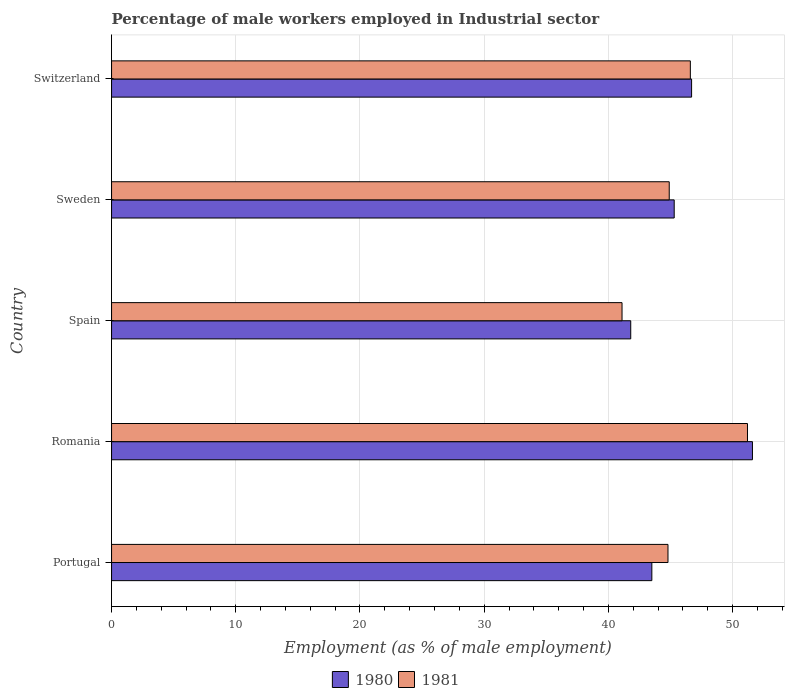How many groups of bars are there?
Offer a terse response. 5. In how many cases, is the number of bars for a given country not equal to the number of legend labels?
Provide a succinct answer. 0. What is the percentage of male workers employed in Industrial sector in 1980 in Portugal?
Your answer should be compact. 43.5. Across all countries, what is the maximum percentage of male workers employed in Industrial sector in 1981?
Offer a very short reply. 51.2. Across all countries, what is the minimum percentage of male workers employed in Industrial sector in 1981?
Offer a very short reply. 41.1. In which country was the percentage of male workers employed in Industrial sector in 1980 maximum?
Your response must be concise. Romania. In which country was the percentage of male workers employed in Industrial sector in 1981 minimum?
Keep it short and to the point. Spain. What is the total percentage of male workers employed in Industrial sector in 1981 in the graph?
Keep it short and to the point. 228.6. What is the difference between the percentage of male workers employed in Industrial sector in 1981 in Spain and that in Sweden?
Your answer should be compact. -3.8. What is the difference between the percentage of male workers employed in Industrial sector in 1981 in Romania and the percentage of male workers employed in Industrial sector in 1980 in Sweden?
Offer a terse response. 5.9. What is the average percentage of male workers employed in Industrial sector in 1981 per country?
Provide a succinct answer. 45.72. What is the difference between the percentage of male workers employed in Industrial sector in 1981 and percentage of male workers employed in Industrial sector in 1980 in Switzerland?
Make the answer very short. -0.1. What is the ratio of the percentage of male workers employed in Industrial sector in 1981 in Spain to that in Switzerland?
Your answer should be compact. 0.88. Is the percentage of male workers employed in Industrial sector in 1981 in Spain less than that in Sweden?
Make the answer very short. Yes. What is the difference between the highest and the second highest percentage of male workers employed in Industrial sector in 1980?
Ensure brevity in your answer.  4.9. What is the difference between the highest and the lowest percentage of male workers employed in Industrial sector in 1981?
Your answer should be very brief. 10.1. What is the difference between two consecutive major ticks on the X-axis?
Your answer should be compact. 10. Does the graph contain any zero values?
Offer a very short reply. No. What is the title of the graph?
Offer a terse response. Percentage of male workers employed in Industrial sector. What is the label or title of the X-axis?
Your answer should be compact. Employment (as % of male employment). What is the label or title of the Y-axis?
Provide a short and direct response. Country. What is the Employment (as % of male employment) in 1980 in Portugal?
Provide a succinct answer. 43.5. What is the Employment (as % of male employment) in 1981 in Portugal?
Offer a terse response. 44.8. What is the Employment (as % of male employment) of 1980 in Romania?
Make the answer very short. 51.6. What is the Employment (as % of male employment) of 1981 in Romania?
Ensure brevity in your answer.  51.2. What is the Employment (as % of male employment) of 1980 in Spain?
Offer a terse response. 41.8. What is the Employment (as % of male employment) in 1981 in Spain?
Your answer should be compact. 41.1. What is the Employment (as % of male employment) of 1980 in Sweden?
Ensure brevity in your answer.  45.3. What is the Employment (as % of male employment) in 1981 in Sweden?
Ensure brevity in your answer.  44.9. What is the Employment (as % of male employment) of 1980 in Switzerland?
Your response must be concise. 46.7. What is the Employment (as % of male employment) of 1981 in Switzerland?
Keep it short and to the point. 46.6. Across all countries, what is the maximum Employment (as % of male employment) of 1980?
Give a very brief answer. 51.6. Across all countries, what is the maximum Employment (as % of male employment) of 1981?
Provide a short and direct response. 51.2. Across all countries, what is the minimum Employment (as % of male employment) of 1980?
Ensure brevity in your answer.  41.8. Across all countries, what is the minimum Employment (as % of male employment) in 1981?
Keep it short and to the point. 41.1. What is the total Employment (as % of male employment) in 1980 in the graph?
Provide a short and direct response. 228.9. What is the total Employment (as % of male employment) of 1981 in the graph?
Your answer should be very brief. 228.6. What is the difference between the Employment (as % of male employment) of 1981 in Portugal and that in Romania?
Make the answer very short. -6.4. What is the difference between the Employment (as % of male employment) in 1980 in Portugal and that in Sweden?
Make the answer very short. -1.8. What is the difference between the Employment (as % of male employment) of 1981 in Portugal and that in Sweden?
Keep it short and to the point. -0.1. What is the difference between the Employment (as % of male employment) of 1980 in Portugal and that in Switzerland?
Offer a very short reply. -3.2. What is the difference between the Employment (as % of male employment) of 1980 in Romania and that in Sweden?
Make the answer very short. 6.3. What is the difference between the Employment (as % of male employment) of 1981 in Spain and that in Sweden?
Make the answer very short. -3.8. What is the difference between the Employment (as % of male employment) in 1980 in Spain and that in Switzerland?
Provide a succinct answer. -4.9. What is the difference between the Employment (as % of male employment) in 1981 in Spain and that in Switzerland?
Keep it short and to the point. -5.5. What is the difference between the Employment (as % of male employment) of 1980 in Sweden and that in Switzerland?
Provide a short and direct response. -1.4. What is the difference between the Employment (as % of male employment) of 1981 in Sweden and that in Switzerland?
Your response must be concise. -1.7. What is the difference between the Employment (as % of male employment) in 1980 in Romania and the Employment (as % of male employment) in 1981 in Spain?
Your answer should be very brief. 10.5. What is the difference between the Employment (as % of male employment) of 1980 in Romania and the Employment (as % of male employment) of 1981 in Sweden?
Offer a very short reply. 6.7. What is the difference between the Employment (as % of male employment) in 1980 in Spain and the Employment (as % of male employment) in 1981 in Sweden?
Keep it short and to the point. -3.1. What is the difference between the Employment (as % of male employment) of 1980 in Sweden and the Employment (as % of male employment) of 1981 in Switzerland?
Make the answer very short. -1.3. What is the average Employment (as % of male employment) of 1980 per country?
Your answer should be very brief. 45.78. What is the average Employment (as % of male employment) in 1981 per country?
Offer a terse response. 45.72. What is the difference between the Employment (as % of male employment) in 1980 and Employment (as % of male employment) in 1981 in Romania?
Provide a short and direct response. 0.4. What is the difference between the Employment (as % of male employment) in 1980 and Employment (as % of male employment) in 1981 in Spain?
Offer a very short reply. 0.7. What is the difference between the Employment (as % of male employment) in 1980 and Employment (as % of male employment) in 1981 in Sweden?
Offer a terse response. 0.4. What is the ratio of the Employment (as % of male employment) of 1980 in Portugal to that in Romania?
Offer a terse response. 0.84. What is the ratio of the Employment (as % of male employment) of 1981 in Portugal to that in Romania?
Offer a terse response. 0.88. What is the ratio of the Employment (as % of male employment) of 1980 in Portugal to that in Spain?
Your answer should be very brief. 1.04. What is the ratio of the Employment (as % of male employment) of 1981 in Portugal to that in Spain?
Your answer should be very brief. 1.09. What is the ratio of the Employment (as % of male employment) of 1980 in Portugal to that in Sweden?
Offer a very short reply. 0.96. What is the ratio of the Employment (as % of male employment) of 1981 in Portugal to that in Sweden?
Make the answer very short. 1. What is the ratio of the Employment (as % of male employment) of 1980 in Portugal to that in Switzerland?
Make the answer very short. 0.93. What is the ratio of the Employment (as % of male employment) of 1981 in Portugal to that in Switzerland?
Keep it short and to the point. 0.96. What is the ratio of the Employment (as % of male employment) of 1980 in Romania to that in Spain?
Your answer should be compact. 1.23. What is the ratio of the Employment (as % of male employment) in 1981 in Romania to that in Spain?
Ensure brevity in your answer.  1.25. What is the ratio of the Employment (as % of male employment) in 1980 in Romania to that in Sweden?
Your answer should be very brief. 1.14. What is the ratio of the Employment (as % of male employment) in 1981 in Romania to that in Sweden?
Offer a terse response. 1.14. What is the ratio of the Employment (as % of male employment) of 1980 in Romania to that in Switzerland?
Offer a very short reply. 1.1. What is the ratio of the Employment (as % of male employment) in 1981 in Romania to that in Switzerland?
Give a very brief answer. 1.1. What is the ratio of the Employment (as % of male employment) of 1980 in Spain to that in Sweden?
Your answer should be compact. 0.92. What is the ratio of the Employment (as % of male employment) of 1981 in Spain to that in Sweden?
Keep it short and to the point. 0.92. What is the ratio of the Employment (as % of male employment) of 1980 in Spain to that in Switzerland?
Provide a short and direct response. 0.9. What is the ratio of the Employment (as % of male employment) of 1981 in Spain to that in Switzerland?
Ensure brevity in your answer.  0.88. What is the ratio of the Employment (as % of male employment) of 1981 in Sweden to that in Switzerland?
Ensure brevity in your answer.  0.96. What is the difference between the highest and the second highest Employment (as % of male employment) in 1980?
Offer a very short reply. 4.9. What is the difference between the highest and the second highest Employment (as % of male employment) in 1981?
Keep it short and to the point. 4.6. What is the difference between the highest and the lowest Employment (as % of male employment) in 1980?
Keep it short and to the point. 9.8. 